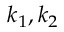Convert formula to latex. <formula><loc_0><loc_0><loc_500><loc_500>k _ { 1 } , k _ { 2 }</formula> 